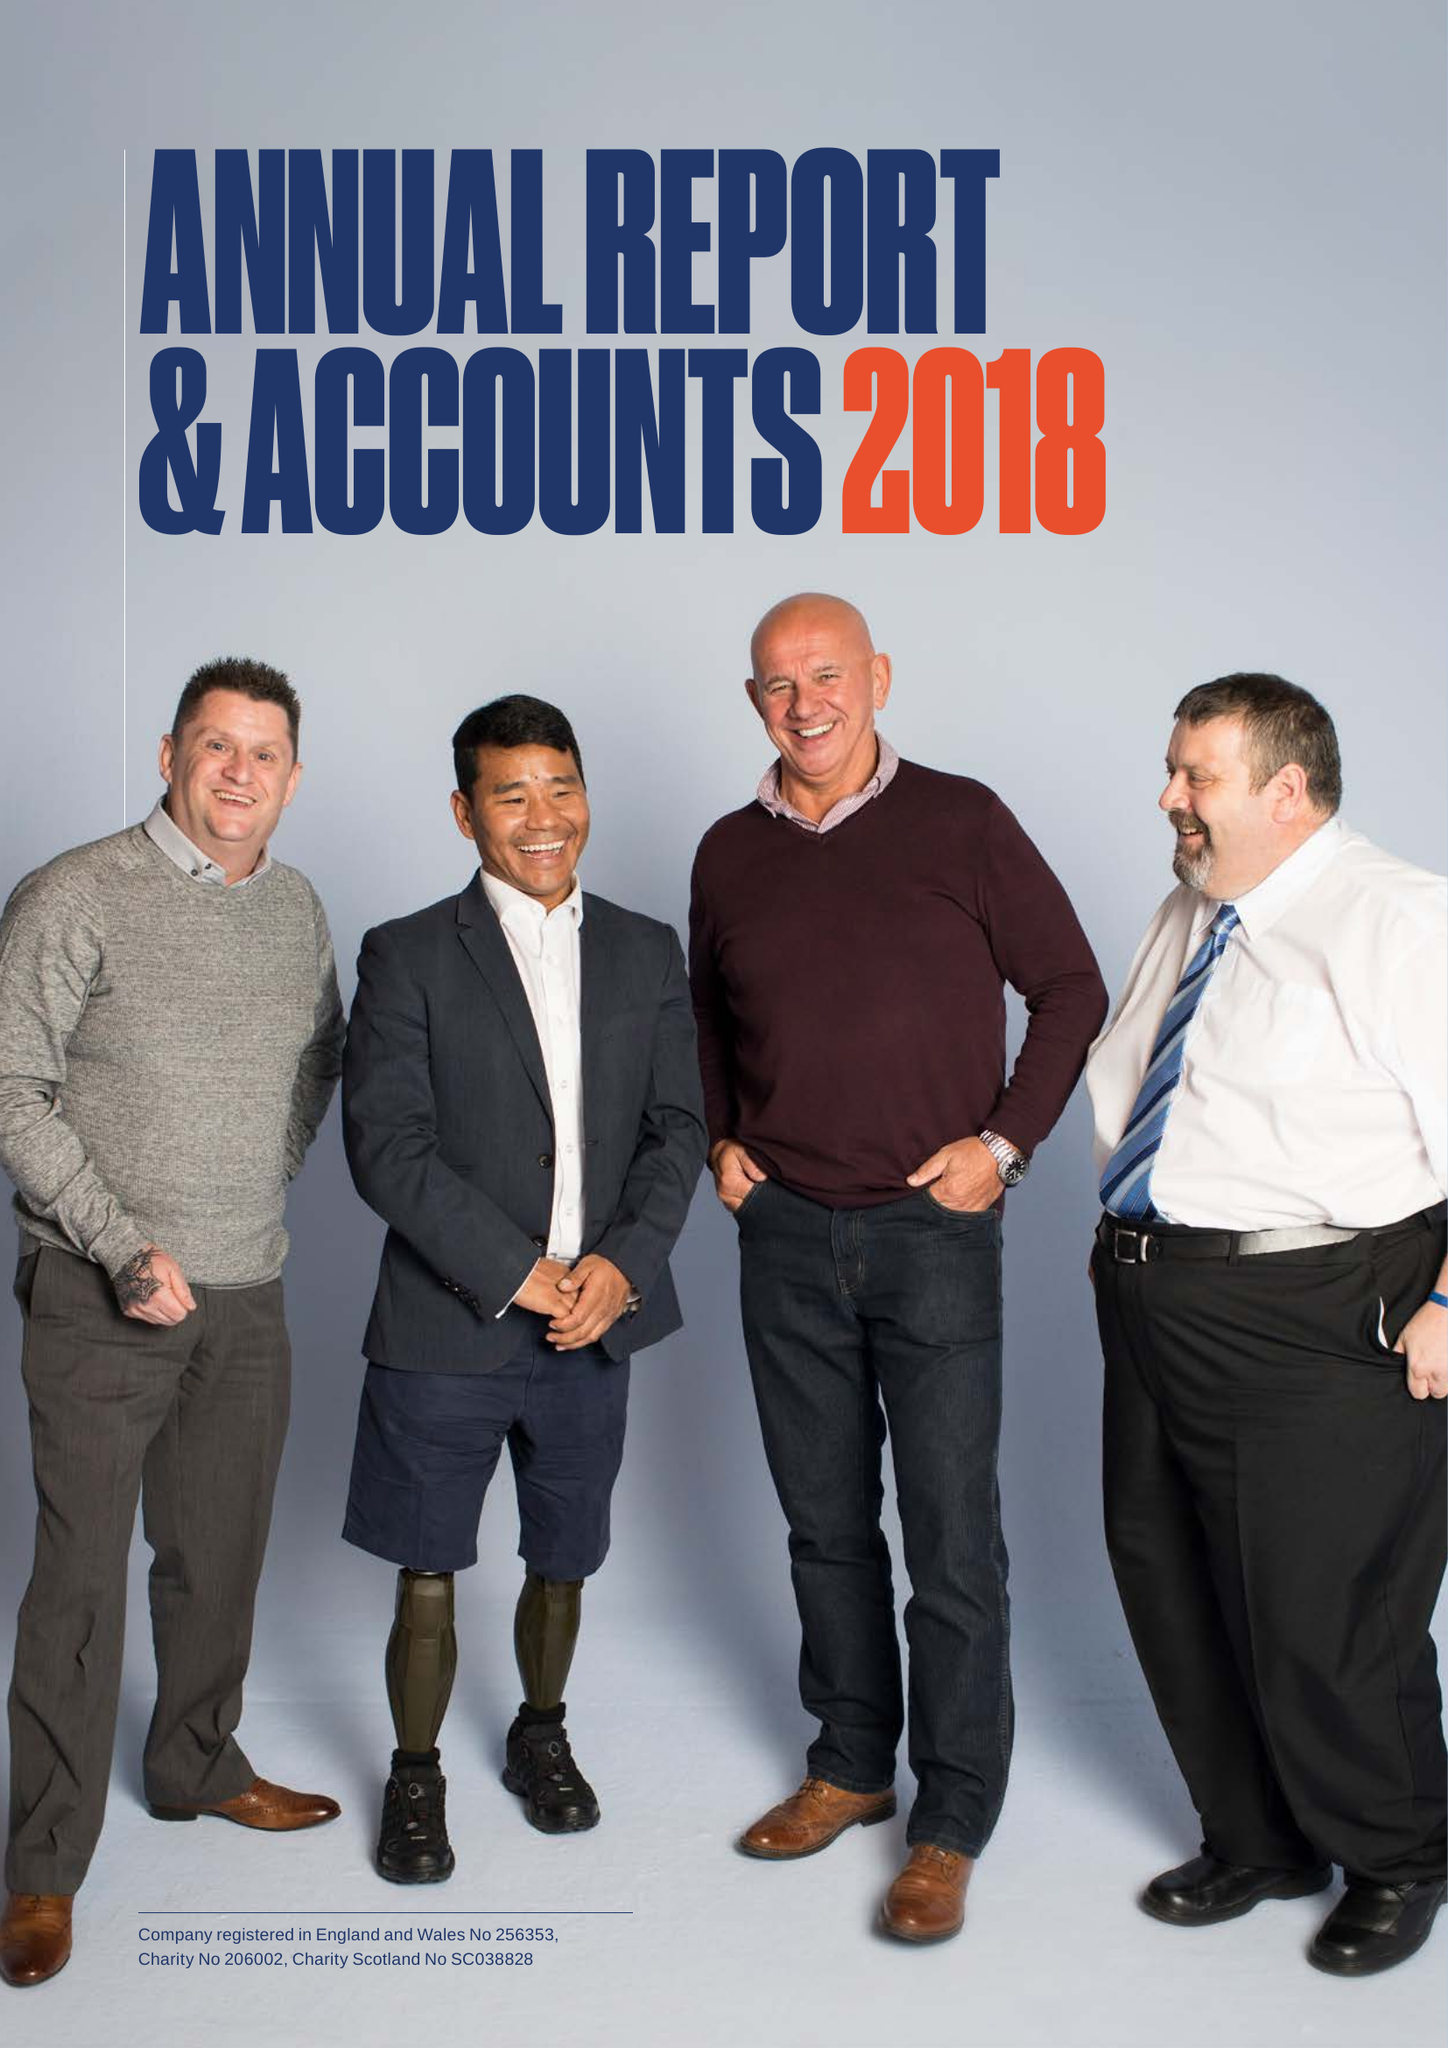What is the value for the charity_name?
Answer the question using a single word or phrase. Combat Stress 